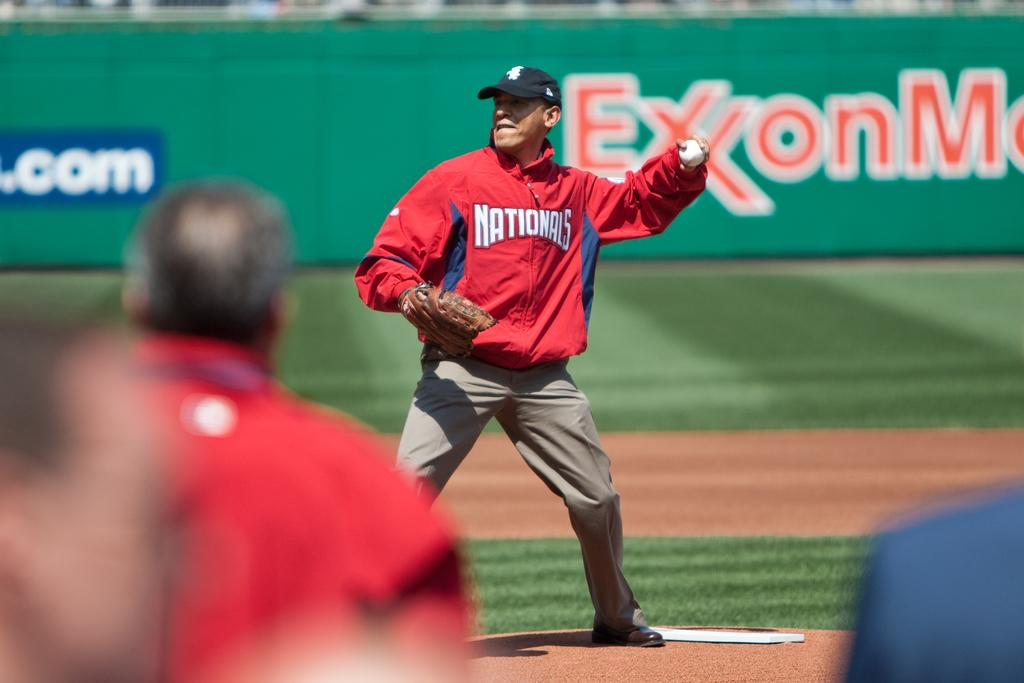<image>
Render a clear and concise summary of the photo. A man wearing a Nationals jacket and khaki pants standing an the pitchers mound and throwing a baseball. 